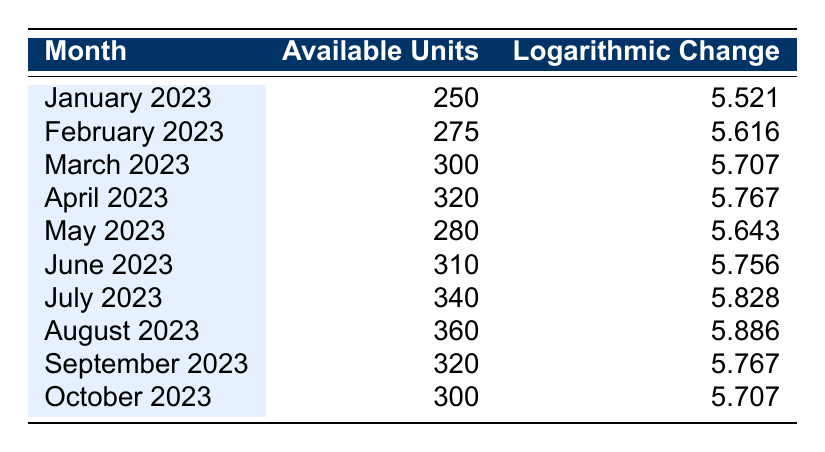What month had the highest number of available units? By examining the “Available Units” column, we see that August 2023 has the highest value of 360 available units.
Answer: August 2023 What was the logarithmic change for May 2023? Looking at the “Logarithmic Change” column for May 2023, the value is 5.643.
Answer: 5.643 What is the total number of available units from January to April 2023? Adding the values in the “Available Units” column from January to April gives us 250 + 275 + 300 + 320 = 1145.
Answer: 1145 Was there a decrease in available units from August to September 2023? By checking the “Available Units” for August (360) and September (320), we see a decrease of 40 units. Thus, there was a decrease.
Answer: Yes What is the average logarithmic change from January to July 2023? To find the average from January to July, we add the logarithmic changes for those months: 5.521 + 5.616 + 5.707 + 5.767 + 5.643 + 5.756 + 5.828 = 40.838. Dividing by 7 gives us an average of 5.834.
Answer: 5.834 Which month had a logarithmic change closest to 5.7? Comparing the “Logarithmic Change” values, both March 2023 (5.707) and October 2023 (5.707) have values that are closest to 5.7.
Answer: March 2023 and October 2023 What was the change in available units from June to July 2023? Looking at June 2023 (310) and July 2023 (340), we find the change by subtracting: 340 - 310 = 30.
Answer: 30 Was the available units in February higher than in May 2023? Comparing February 2023 (275 available units) and May 2023 (280 available units), we see that May had more units than February. Therefore, this statement is false.
Answer: No What is the difference in logarithmic change between the highest and lowest months? The highest logarithmic change is for August 2023 (5.886), and the lowest is for January 2023 (5.521). The difference is 5.886 - 5.521 = 0.365.
Answer: 0.365 